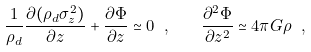Convert formula to latex. <formula><loc_0><loc_0><loc_500><loc_500>\frac { 1 } { \rho _ { d } } \frac { \partial ( \rho _ { d } \sigma _ { z } ^ { 2 } ) } { \partial z } + \frac { \partial \Phi } { \partial z } \simeq 0 \ , \quad \frac { \partial ^ { 2 } \Phi } { \partial z ^ { 2 } } \simeq 4 \pi G \rho \ ,</formula> 